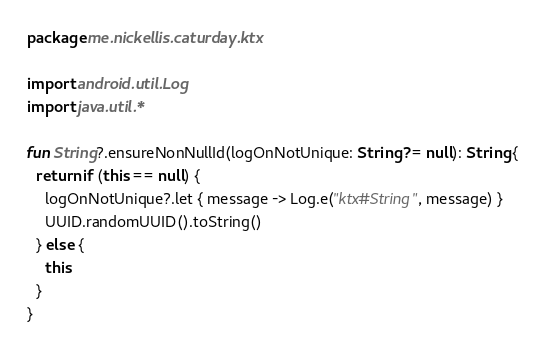Convert code to text. <code><loc_0><loc_0><loc_500><loc_500><_Kotlin_>package me.nickellis.caturday.ktx

import android.util.Log
import java.util.*

fun String?.ensureNonNullId(logOnNotUnique: String? = null): String {
  return if (this == null) {
    logOnNotUnique?.let { message -> Log.e("ktx#String", message) }
    UUID.randomUUID().toString()
  } else {
    this
  }
}</code> 